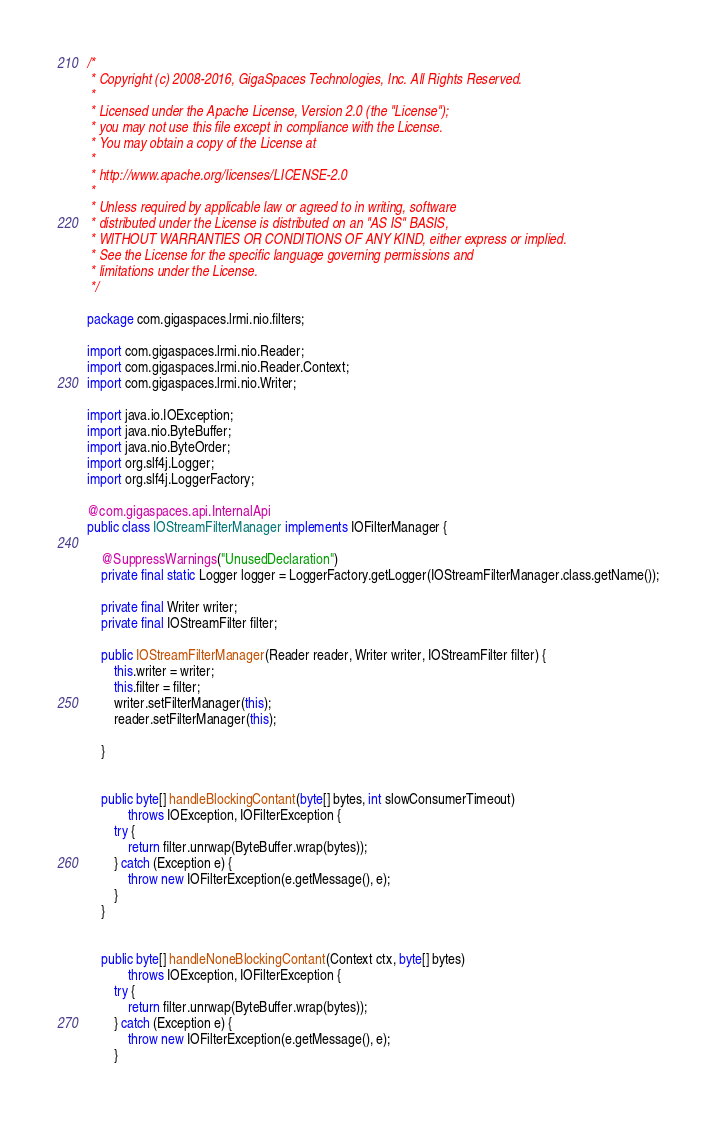<code> <loc_0><loc_0><loc_500><loc_500><_Java_>/*
 * Copyright (c) 2008-2016, GigaSpaces Technologies, Inc. All Rights Reserved.
 *
 * Licensed under the Apache License, Version 2.0 (the "License");
 * you may not use this file except in compliance with the License.
 * You may obtain a copy of the License at
 *
 * http://www.apache.org/licenses/LICENSE-2.0
 *
 * Unless required by applicable law or agreed to in writing, software
 * distributed under the License is distributed on an "AS IS" BASIS,
 * WITHOUT WARRANTIES OR CONDITIONS OF ANY KIND, either express or implied.
 * See the License for the specific language governing permissions and
 * limitations under the License.
 */

package com.gigaspaces.lrmi.nio.filters;

import com.gigaspaces.lrmi.nio.Reader;
import com.gigaspaces.lrmi.nio.Reader.Context;
import com.gigaspaces.lrmi.nio.Writer;

import java.io.IOException;
import java.nio.ByteBuffer;
import java.nio.ByteOrder;
import org.slf4j.Logger;
import org.slf4j.LoggerFactory;

@com.gigaspaces.api.InternalApi
public class IOStreamFilterManager implements IOFilterManager {

    @SuppressWarnings("UnusedDeclaration")
    private final static Logger logger = LoggerFactory.getLogger(IOStreamFilterManager.class.getName());

    private final Writer writer;
    private final IOStreamFilter filter;

    public IOStreamFilterManager(Reader reader, Writer writer, IOStreamFilter filter) {
        this.writer = writer;
        this.filter = filter;
        writer.setFilterManager(this);
        reader.setFilterManager(this);

    }


    public byte[] handleBlockingContant(byte[] bytes, int slowConsumerTimeout)
            throws IOException, IOFilterException {
        try {
            return filter.unrwap(ByteBuffer.wrap(bytes));
        } catch (Exception e) {
            throw new IOFilterException(e.getMessage(), e);
        }
    }


    public byte[] handleNoneBlockingContant(Context ctx, byte[] bytes)
            throws IOException, IOFilterException {
        try {
            return filter.unrwap(ByteBuffer.wrap(bytes));
        } catch (Exception e) {
            throw new IOFilterException(e.getMessage(), e);
        }</code> 